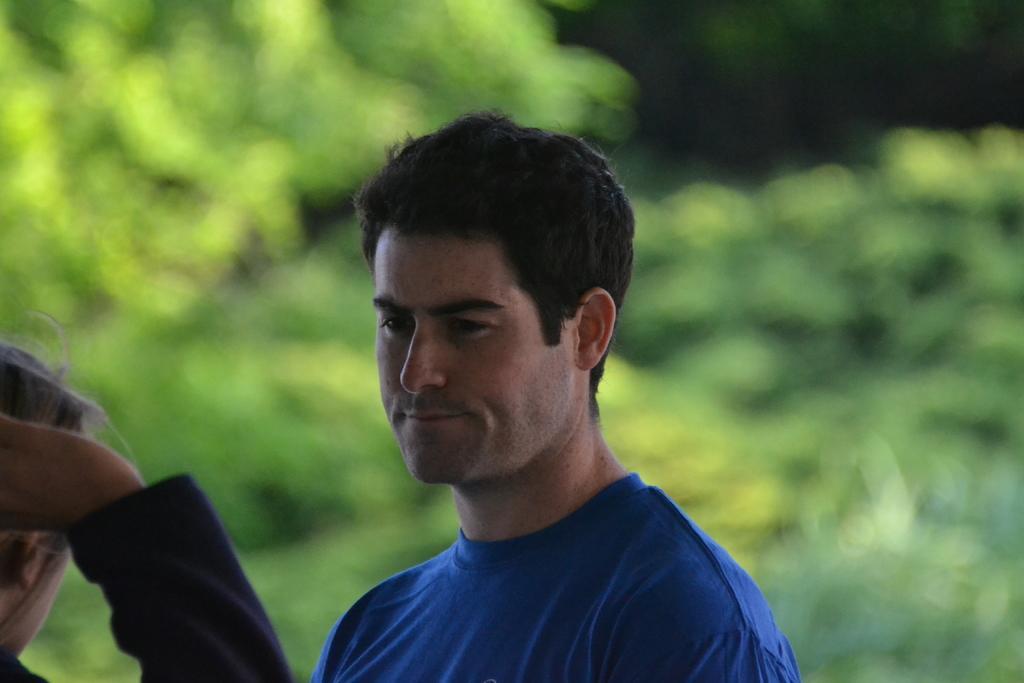In one or two sentences, can you explain what this image depicts? In this image at front there are two persons and at the background there are trees. 